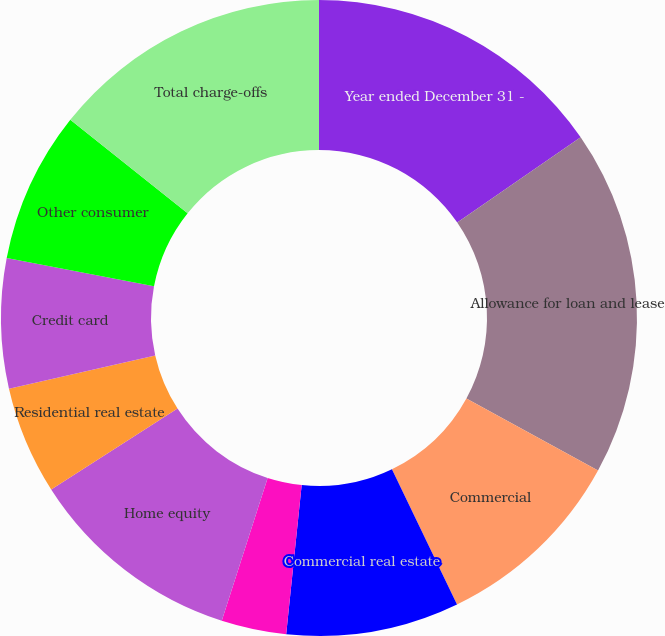Convert chart. <chart><loc_0><loc_0><loc_500><loc_500><pie_chart><fcel>Year ended December 31 -<fcel>Allowance for loan and lease<fcel>Commercial<fcel>Commercial real estate<fcel>Equipment lease financing<fcel>Home equity<fcel>Residential real estate<fcel>Credit card<fcel>Other consumer<fcel>Total charge-offs<nl><fcel>15.38%<fcel>17.58%<fcel>9.89%<fcel>8.79%<fcel>3.3%<fcel>10.99%<fcel>5.49%<fcel>6.59%<fcel>7.69%<fcel>14.29%<nl></chart> 